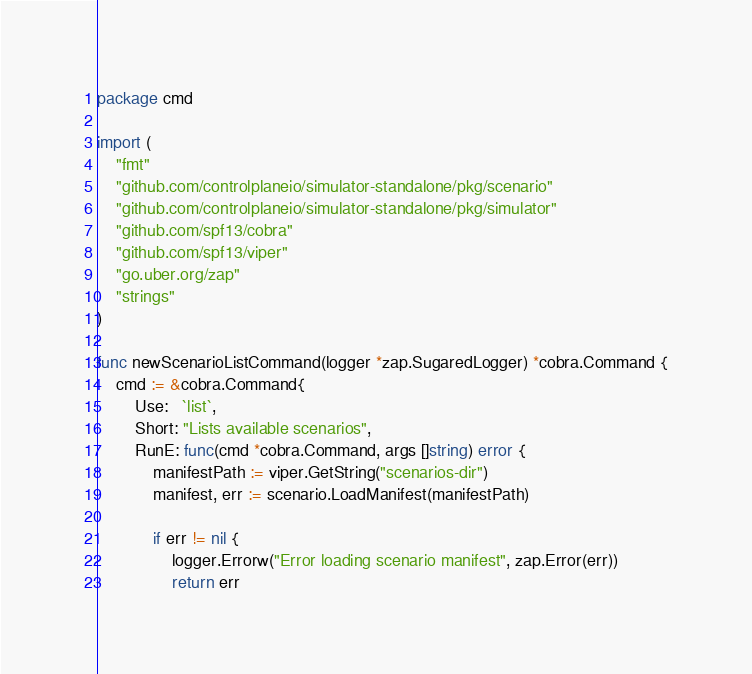Convert code to text. <code><loc_0><loc_0><loc_500><loc_500><_Go_>package cmd

import (
	"fmt"
	"github.com/controlplaneio/simulator-standalone/pkg/scenario"
	"github.com/controlplaneio/simulator-standalone/pkg/simulator"
	"github.com/spf13/cobra"
	"github.com/spf13/viper"
	"go.uber.org/zap"
	"strings"
)

func newScenarioListCommand(logger *zap.SugaredLogger) *cobra.Command {
	cmd := &cobra.Command{
		Use:   `list`,
		Short: "Lists available scenarios",
		RunE: func(cmd *cobra.Command, args []string) error {
			manifestPath := viper.GetString("scenarios-dir")
			manifest, err := scenario.LoadManifest(manifestPath)

			if err != nil {
				logger.Errorw("Error loading scenario manifest", zap.Error(err))
				return err</code> 